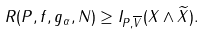<formula> <loc_0><loc_0><loc_500><loc_500>R ( P , f , g _ { \alpha } , N ) \geq I _ { P , \overline { V } } ( X \wedge \widetilde { X } ) .</formula> 